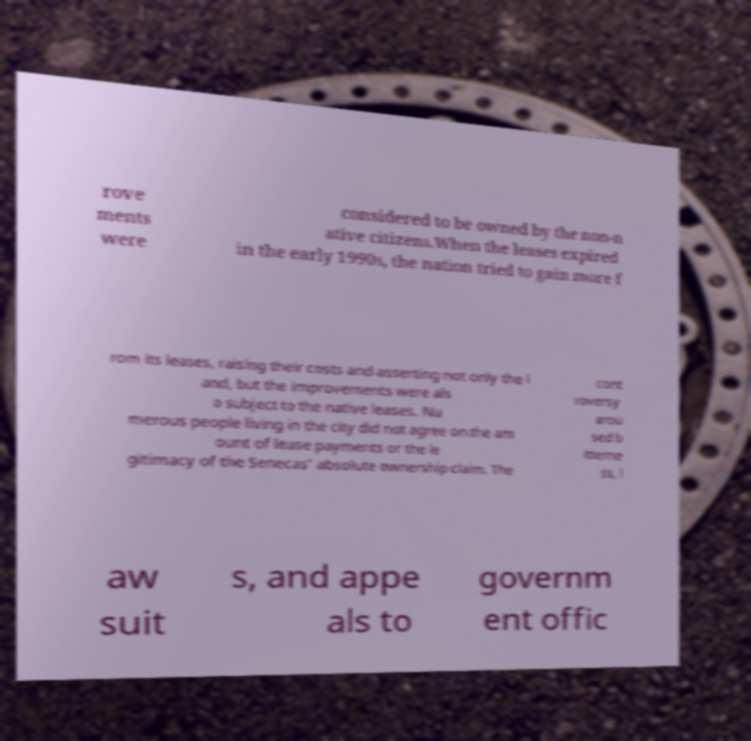There's text embedded in this image that I need extracted. Can you transcribe it verbatim? rove ments were considered to be owned by the non-n ative citizens.When the leases expired in the early 1990s, the nation tried to gain more f rom its leases, raising their costs and asserting not only the l and, but the improvements were als o subject to the native leases. Nu merous people living in the city did not agree on the am ount of lease payments or the le gitimacy of the Senecas' absolute ownership claim. The cont roversy arou sed b itterne ss, l aw suit s, and appe als to governm ent offic 